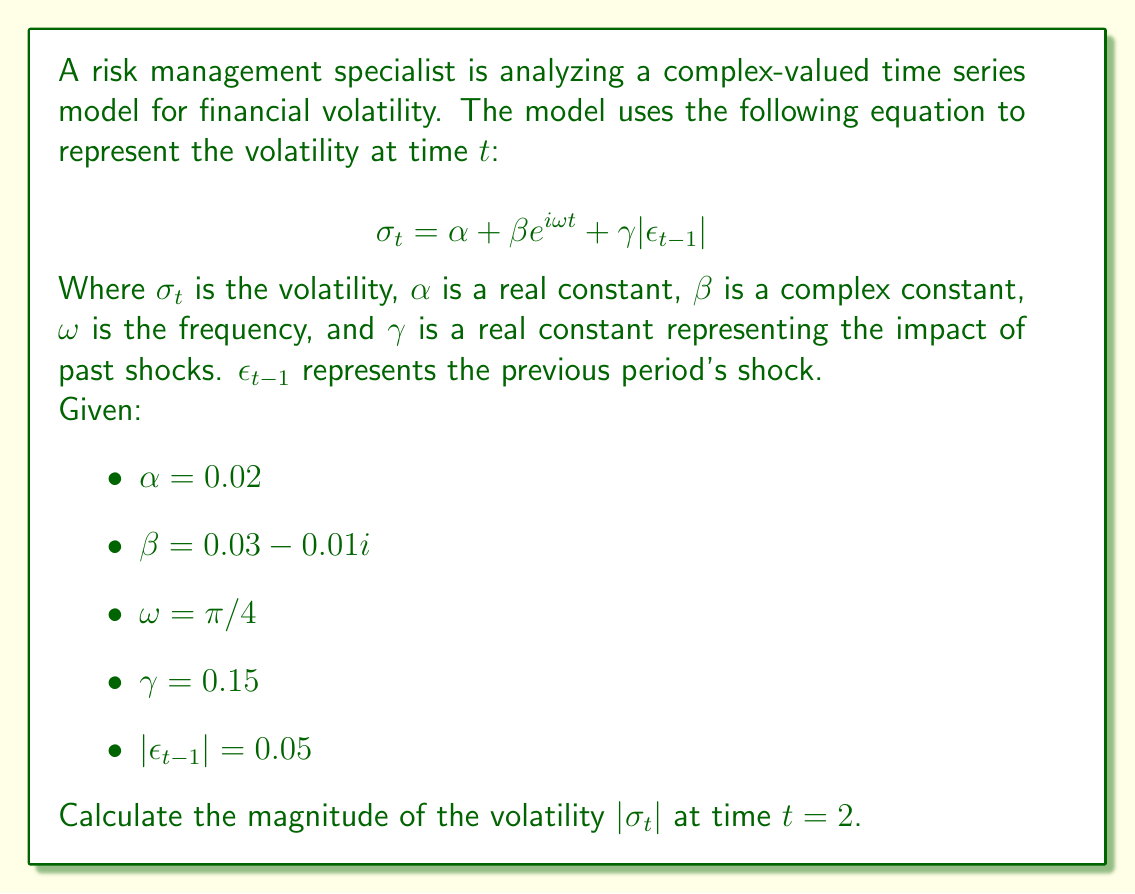Can you answer this question? To solve this problem, we need to follow these steps:

1) First, let's substitute the given values into the equation:

   $$\sigma_2 = 0.02 + (0.03 - 0.01i) e^{i\pi/2} + 0.15(0.05)$$

2) Let's evaluate $e^{i\pi/2}$:
   
   $$e^{i\pi/2} = \cos(\pi/2) + i\sin(\pi/2) = i$$

3) Now we can simplify the equation:

   $$\sigma_2 = 0.02 + (0.03 - 0.01i)(i) + 0.15(0.05)$$

4) Multiply the complex numbers:

   $$(0.03 - 0.01i)(i) = 0.03i - 0.01i^2 = 0.03i + 0.01$$

5) Substitute this back and simplify:

   $$\sigma_2 = 0.02 + (0.01 + 0.03i) + 0.15(0.05)$$
   $$\sigma_2 = 0.02 + 0.01 + 0.03i + 0.0075$$
   $$\sigma_2 = 0.0375 + 0.03i$$

6) To find the magnitude of this complex number, we use the formula $|a+bi| = \sqrt{a^2 + b^2}$:

   $$|\sigma_2| = \sqrt{0.0375^2 + 0.03^2}$$

7) Calculate:

   $$|\sigma_2| = \sqrt{0.00140625 + 0.0009}$$
   $$|\sigma_2| = \sqrt{0.00230625}$$
   $$|\sigma_2| = 0.048023$$

Therefore, the magnitude of the volatility at time $t=2$ is approximately 0.048023.
Answer: $|\sigma_2| \approx 0.048023$ 